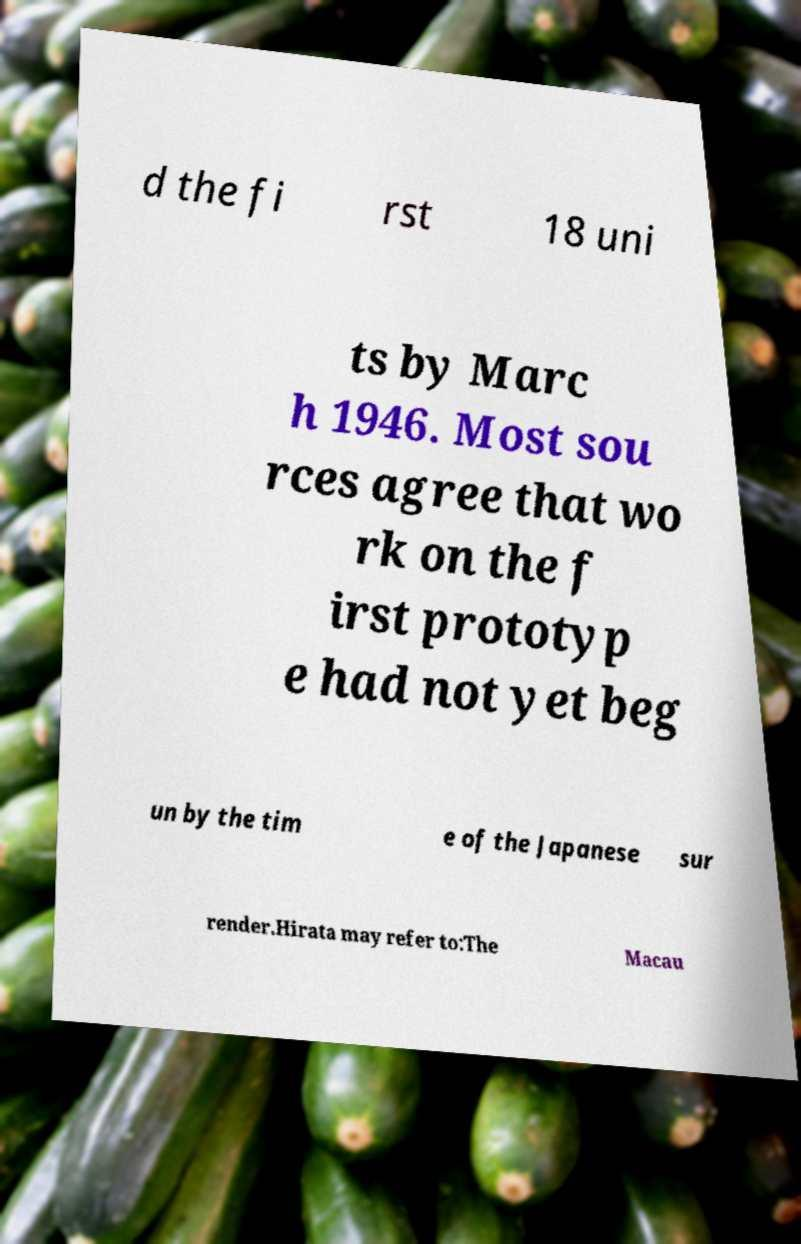Can you read and provide the text displayed in the image?This photo seems to have some interesting text. Can you extract and type it out for me? d the fi rst 18 uni ts by Marc h 1946. Most sou rces agree that wo rk on the f irst prototyp e had not yet beg un by the tim e of the Japanese sur render.Hirata may refer to:The Macau 